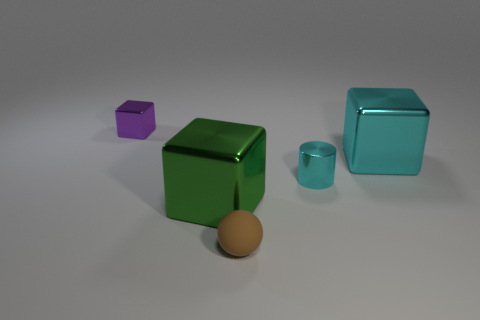Add 3 yellow rubber blocks. How many objects exist? 8 Subtract all spheres. How many objects are left? 4 Subtract all large things. Subtract all small brown balls. How many objects are left? 2 Add 4 brown matte things. How many brown matte things are left? 5 Add 2 large gray cubes. How many large gray cubes exist? 2 Subtract 0 blue spheres. How many objects are left? 5 